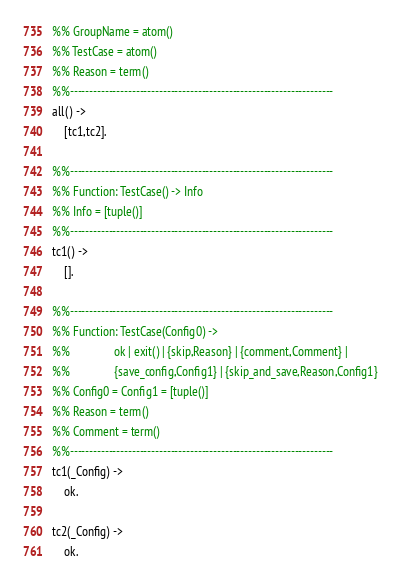<code> <loc_0><loc_0><loc_500><loc_500><_Erlang_>%% GroupName = atom()
%% TestCase = atom()
%% Reason = term()
%%--------------------------------------------------------------------
all() -> 
    [tc1,tc2].

%%--------------------------------------------------------------------
%% Function: TestCase() -> Info
%% Info = [tuple()]
%%--------------------------------------------------------------------
tc1() -> 
    [].

%%--------------------------------------------------------------------
%% Function: TestCase(Config0) ->
%%               ok | exit() | {skip,Reason} | {comment,Comment} |
%%               {save_config,Config1} | {skip_and_save,Reason,Config1}
%% Config0 = Config1 = [tuple()]
%% Reason = term()
%% Comment = term()
%%--------------------------------------------------------------------
tc1(_Config) -> 
    ok.

tc2(_Config) -> 
    ok.
</code> 